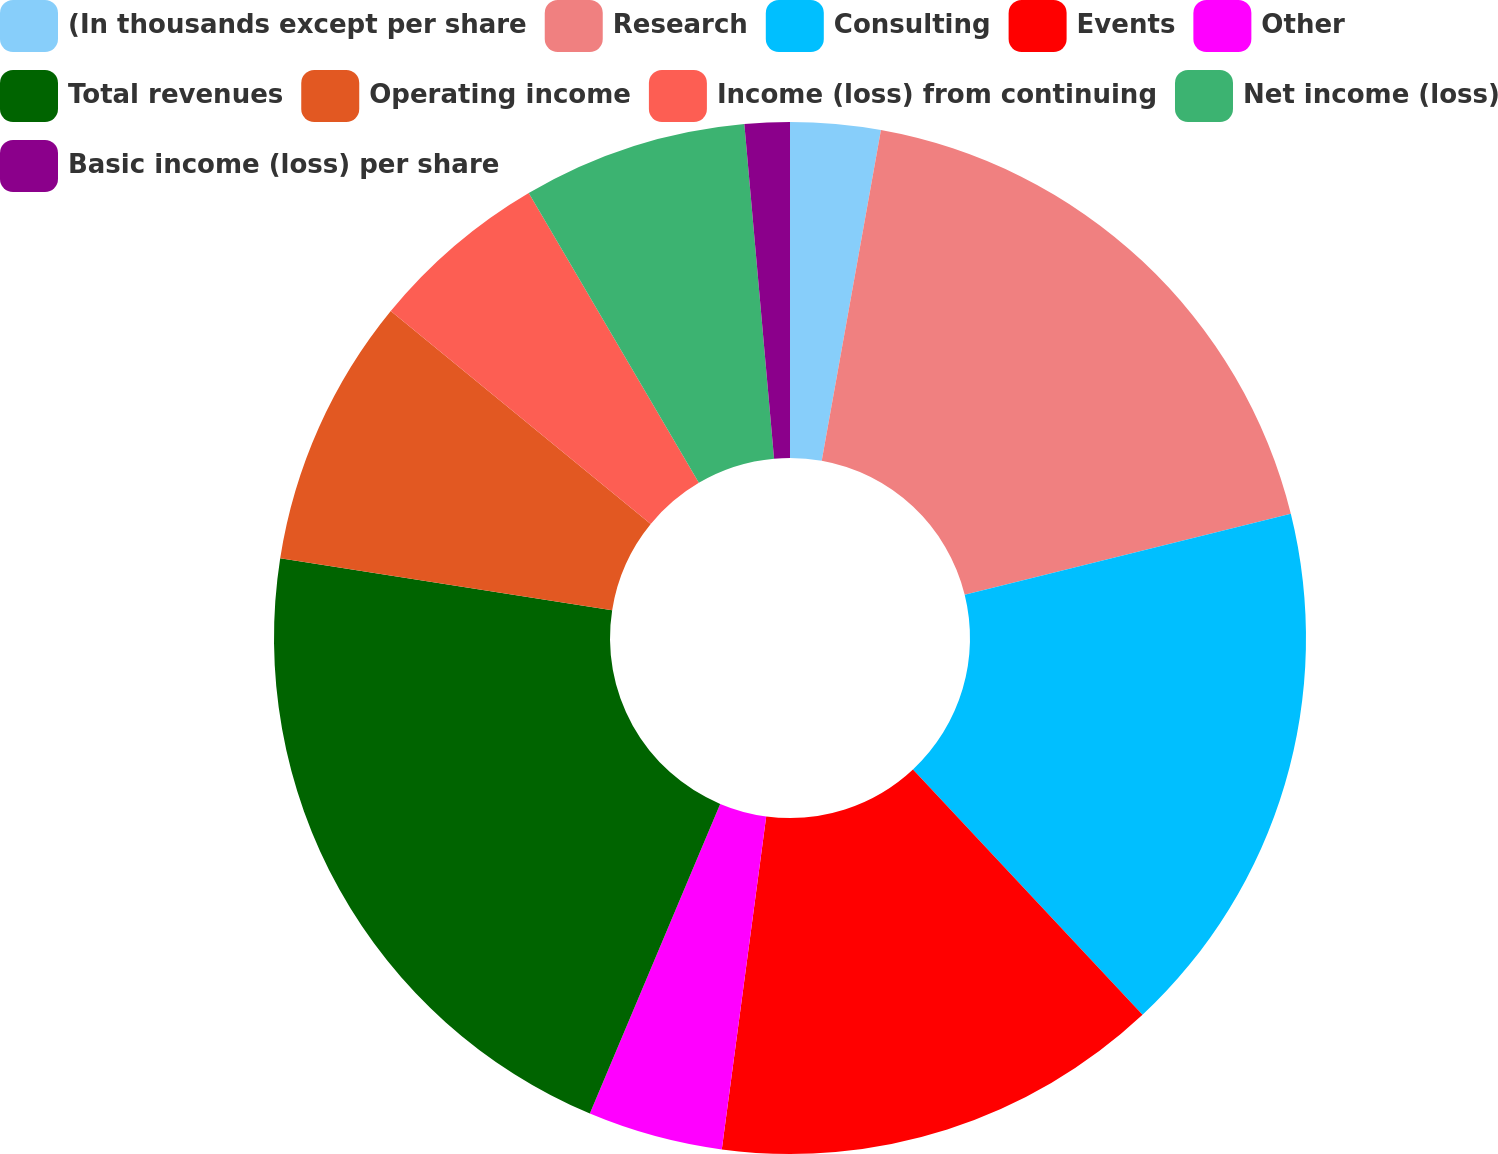<chart> <loc_0><loc_0><loc_500><loc_500><pie_chart><fcel>(In thousands except per share<fcel>Research<fcel>Consulting<fcel>Events<fcel>Other<fcel>Total revenues<fcel>Operating income<fcel>Income (loss) from continuing<fcel>Net income (loss)<fcel>Basic income (loss) per share<nl><fcel>2.82%<fcel>18.31%<fcel>16.9%<fcel>14.08%<fcel>4.23%<fcel>21.13%<fcel>8.45%<fcel>5.63%<fcel>7.04%<fcel>1.41%<nl></chart> 